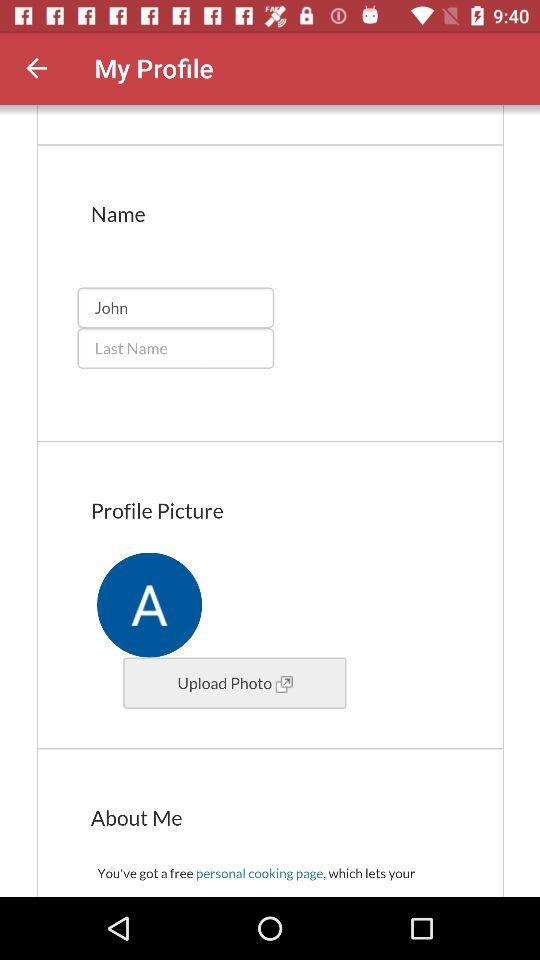What is the first name? The first name is John. 